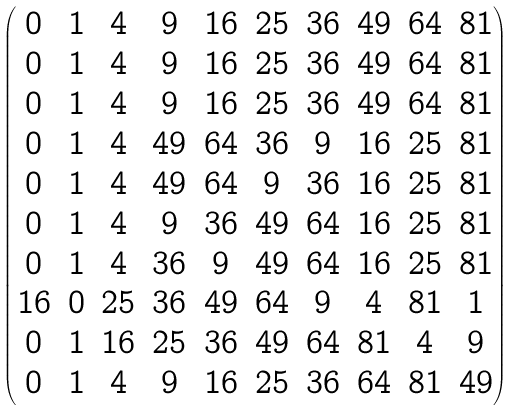<formula> <loc_0><loc_0><loc_500><loc_500>\begin{pmatrix} 0 & 1 & 4 & 9 & 1 6 & 2 5 & 3 6 & 4 9 & 6 4 & 8 1 \\ 0 & 1 & 4 & 9 & 1 6 & 2 5 & 3 6 & 4 9 & 6 4 & 8 1 \\ 0 & 1 & 4 & 9 & 1 6 & 2 5 & 3 6 & 4 9 & 6 4 & 8 1 \\ 0 & 1 & 4 & 4 9 & 6 4 & 3 6 & 9 & 1 6 & 2 5 & 8 1 \\ 0 & 1 & 4 & 4 9 & 6 4 & 9 & 3 6 & 1 6 & 2 5 & 8 1 \\ 0 & 1 & 4 & 9 & 3 6 & 4 9 & 6 4 & 1 6 & 2 5 & 8 1 \\ 0 & 1 & 4 & 3 6 & 9 & 4 9 & 6 4 & 1 6 & 2 5 & 8 1 \\ 1 6 & 0 & 2 5 & 3 6 & 4 9 & 6 4 & 9 & 4 & 8 1 & 1 \\ 0 & 1 & 1 6 & 2 5 & 3 6 & 4 9 & 6 4 & 8 1 & 4 & 9 \\ 0 & 1 & 4 & 9 & 1 6 & 2 5 & 3 6 & 6 4 & 8 1 & 4 9 \end{pmatrix}</formula> 